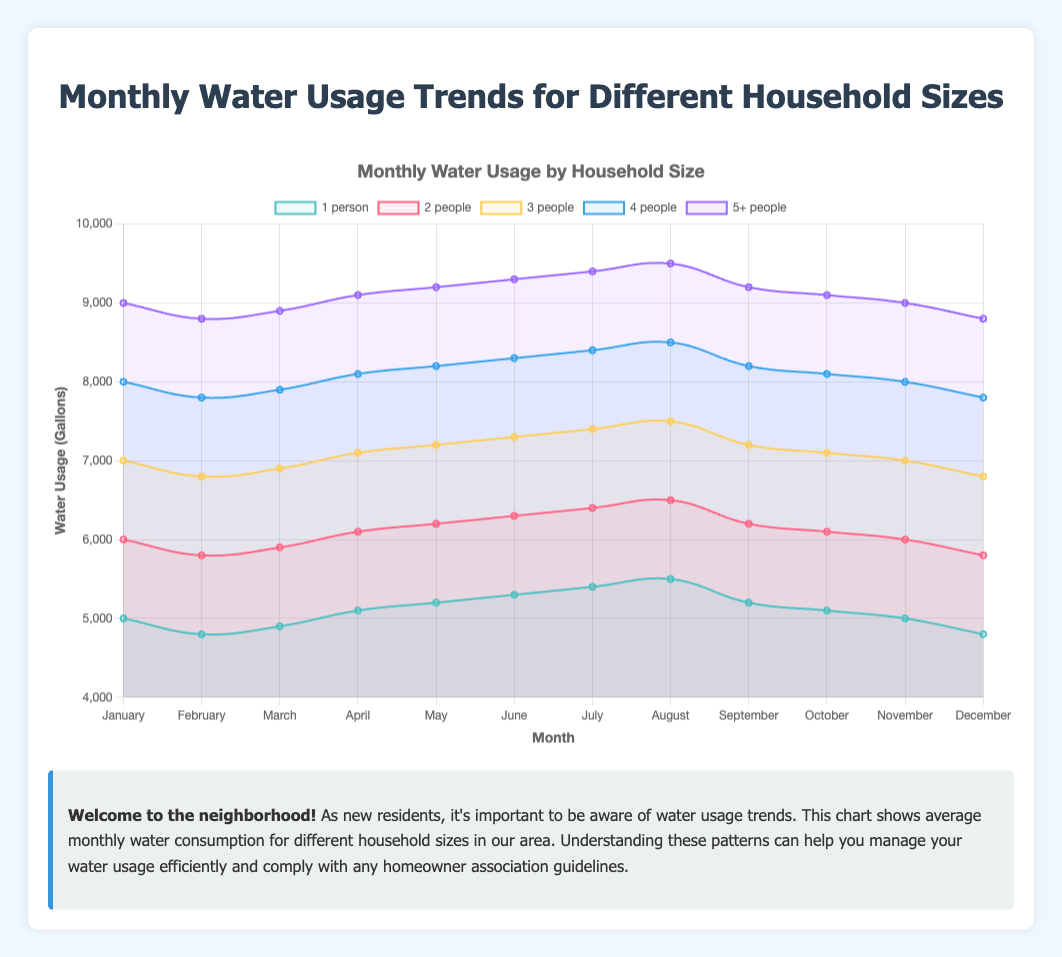What is the water usage in July for a 1-person household? The July water usage for a 1-person household can be identified from the chart by locating the specific point on the line corresponding to the 1-person household in July.
Answer: 5400 gallons Which household size has the highest water usage in December? To determine the household size with the highest water usage in December, look for the highest point among all data points for December across different household sizes.
Answer: 5+ people What is the average water usage for a 2-person household across all months? Sum the water usage values for each month for the 2-person household and divide by the number of months (12). Calculation: (6000 + 5800 + 5900 + 6100 + 6200 + 6300 + 6400 + 6500 + 6200 + 6100 + 6000 + 5800) / 12 = 6183.33
Answer: ~6183 gallons By how much does a 3-person household's water usage in August exceed that in January? The water usage in August for a 3-person household is 7500 gallons, and in January, it is 7000 gallons. The difference is 7500 - 7000 = 500 gallons.
Answer: 500 gallons Compare the water usage in March between a 4-person household and a 5+ person household. Which one is higher and by how much? The water usage in March for a 4-person household is 7900 gallons, and for a 5+ person household, it is 8900 gallons. The difference is 8900 - 7900 = 1000 gallons, with the 5+ person household having higher usage.
Answer: 5+ people, 1000 gallons What is the sum of the water usage in April for 1-person and 4-person households? The water usage in April for a 1-person household is 5100 gallons, and for a 4-person household, it is 8100 gallons. The sum is 5100 + 8100 = 13200 gallons.
Answer: 13200 gallons Which month has the highest water usage for a 2-person household? To find the month with the highest water usage, look at the highest point on the line corresponding to the 2-person household. Observing the chart shows that August has the highest usage at 6500 gallons.
Answer: August Is the water usage more stable throughout the year for a 1-person household or a 3-person household? Stability can be observed by comparing the fluctuations in the line charts for both households. The 1-person household's water usage ranges from 4800 to 5500 gallons, whereas the 3-person household ranges from 6800 to 7500 gallons. The 3-person household has a higher range, indicating less stability.
Answer: 1-person household What is the difference in water usage between the maximum and minimum months for the 5+ people household? The maximum value is 9500 gallons in August and the minimum value is 8800 gallons in February and December. The difference is 9500 - 8800 = 700 gallons.
Answer: 700 gallons 